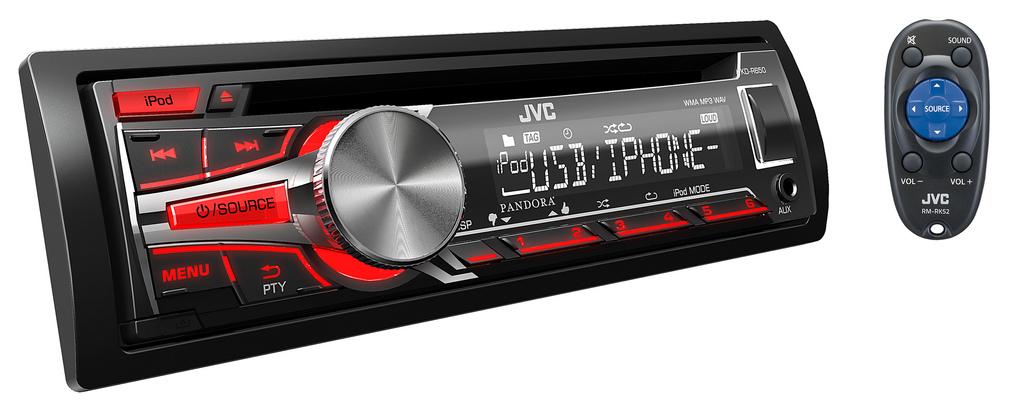Does this phone support usb and iphone?
Offer a very short reply. Yes. 